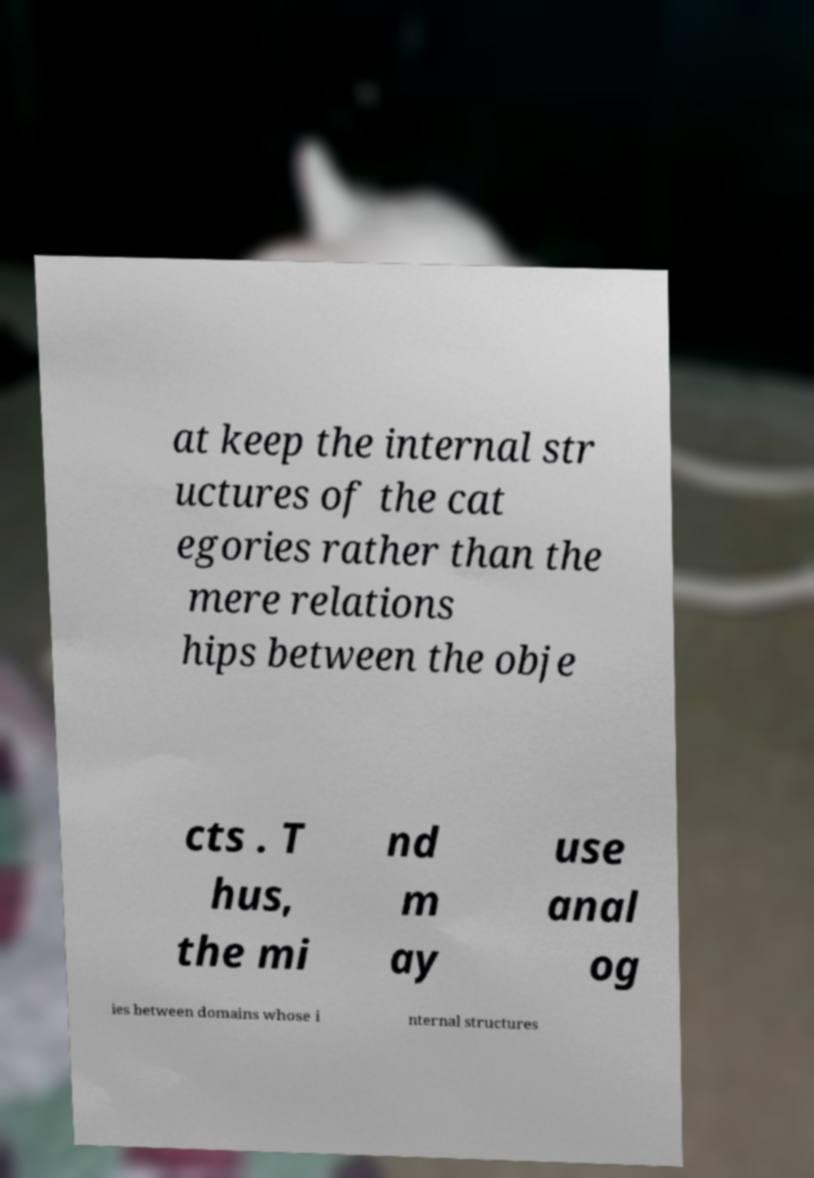Please read and relay the text visible in this image. What does it say? at keep the internal str uctures of the cat egories rather than the mere relations hips between the obje cts . T hus, the mi nd m ay use anal og ies between domains whose i nternal structures 